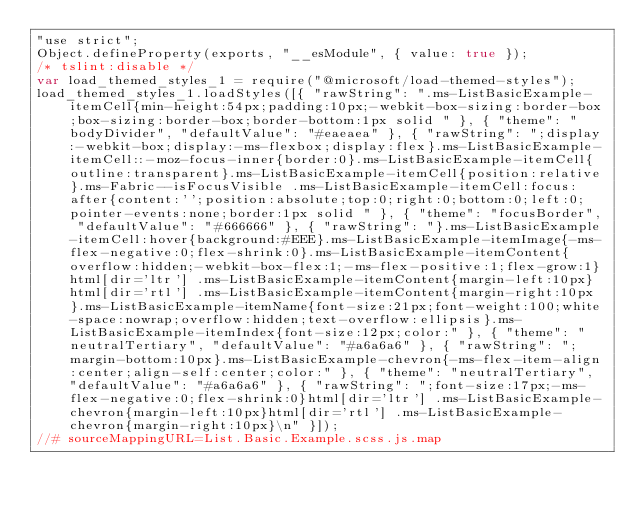Convert code to text. <code><loc_0><loc_0><loc_500><loc_500><_JavaScript_>"use strict";
Object.defineProperty(exports, "__esModule", { value: true });
/* tslint:disable */
var load_themed_styles_1 = require("@microsoft/load-themed-styles");
load_themed_styles_1.loadStyles([{ "rawString": ".ms-ListBasicExample-itemCell{min-height:54px;padding:10px;-webkit-box-sizing:border-box;box-sizing:border-box;border-bottom:1px solid " }, { "theme": "bodyDivider", "defaultValue": "#eaeaea" }, { "rawString": ";display:-webkit-box;display:-ms-flexbox;display:flex}.ms-ListBasicExample-itemCell::-moz-focus-inner{border:0}.ms-ListBasicExample-itemCell{outline:transparent}.ms-ListBasicExample-itemCell{position:relative}.ms-Fabric--isFocusVisible .ms-ListBasicExample-itemCell:focus:after{content:'';position:absolute;top:0;right:0;bottom:0;left:0;pointer-events:none;border:1px solid " }, { "theme": "focusBorder", "defaultValue": "#666666" }, { "rawString": "}.ms-ListBasicExample-itemCell:hover{background:#EEE}.ms-ListBasicExample-itemImage{-ms-flex-negative:0;flex-shrink:0}.ms-ListBasicExample-itemContent{overflow:hidden;-webkit-box-flex:1;-ms-flex-positive:1;flex-grow:1}html[dir='ltr'] .ms-ListBasicExample-itemContent{margin-left:10px}html[dir='rtl'] .ms-ListBasicExample-itemContent{margin-right:10px}.ms-ListBasicExample-itemName{font-size:21px;font-weight:100;white-space:nowrap;overflow:hidden;text-overflow:ellipsis}.ms-ListBasicExample-itemIndex{font-size:12px;color:" }, { "theme": "neutralTertiary", "defaultValue": "#a6a6a6" }, { "rawString": ";margin-bottom:10px}.ms-ListBasicExample-chevron{-ms-flex-item-align:center;align-self:center;color:" }, { "theme": "neutralTertiary", "defaultValue": "#a6a6a6" }, { "rawString": ";font-size:17px;-ms-flex-negative:0;flex-shrink:0}html[dir='ltr'] .ms-ListBasicExample-chevron{margin-left:10px}html[dir='rtl'] .ms-ListBasicExample-chevron{margin-right:10px}\n" }]);
//# sourceMappingURL=List.Basic.Example.scss.js.map</code> 